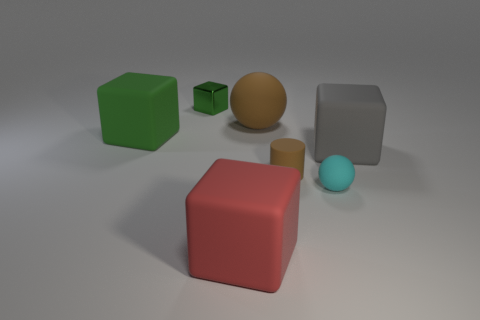What size is the other green thing that is the same shape as the green metal thing?
Give a very brief answer. Large. There is a big red object; what number of big objects are on the left side of it?
Make the answer very short. 1. There is a matte ball behind the big block on the left side of the green metallic block; what color is it?
Your answer should be compact. Brown. Is there any other thing that is the same shape as the large green thing?
Your response must be concise. Yes. Are there an equal number of brown balls to the left of the tiny metal cube and matte cylinders right of the brown matte cylinder?
Offer a very short reply. Yes. How many spheres are gray things or big brown matte things?
Offer a very short reply. 1. How many other objects are there of the same material as the cylinder?
Offer a terse response. 5. What is the shape of the object in front of the cyan thing?
Your response must be concise. Cube. There is a block that is in front of the ball in front of the gray object; what is its material?
Provide a short and direct response. Rubber. Are there more matte blocks that are right of the matte cylinder than tiny shiny things?
Make the answer very short. No. 